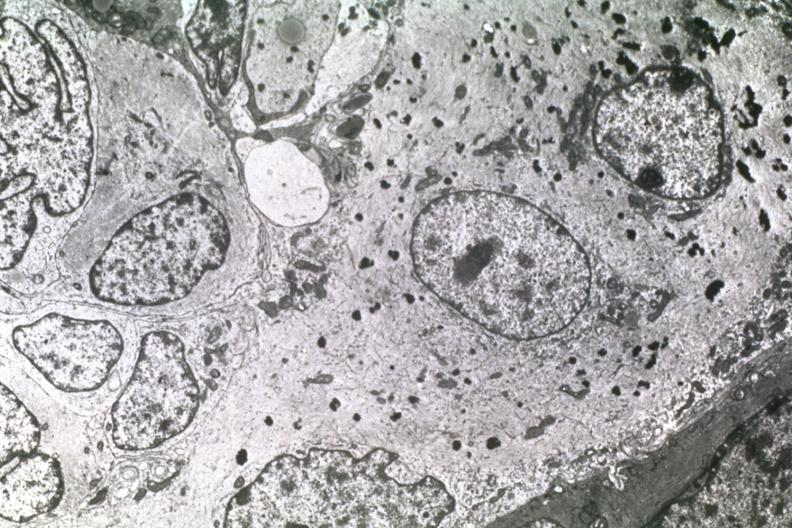what is present?
Answer the question using a single word or phrase. Papillary astrocytoma 